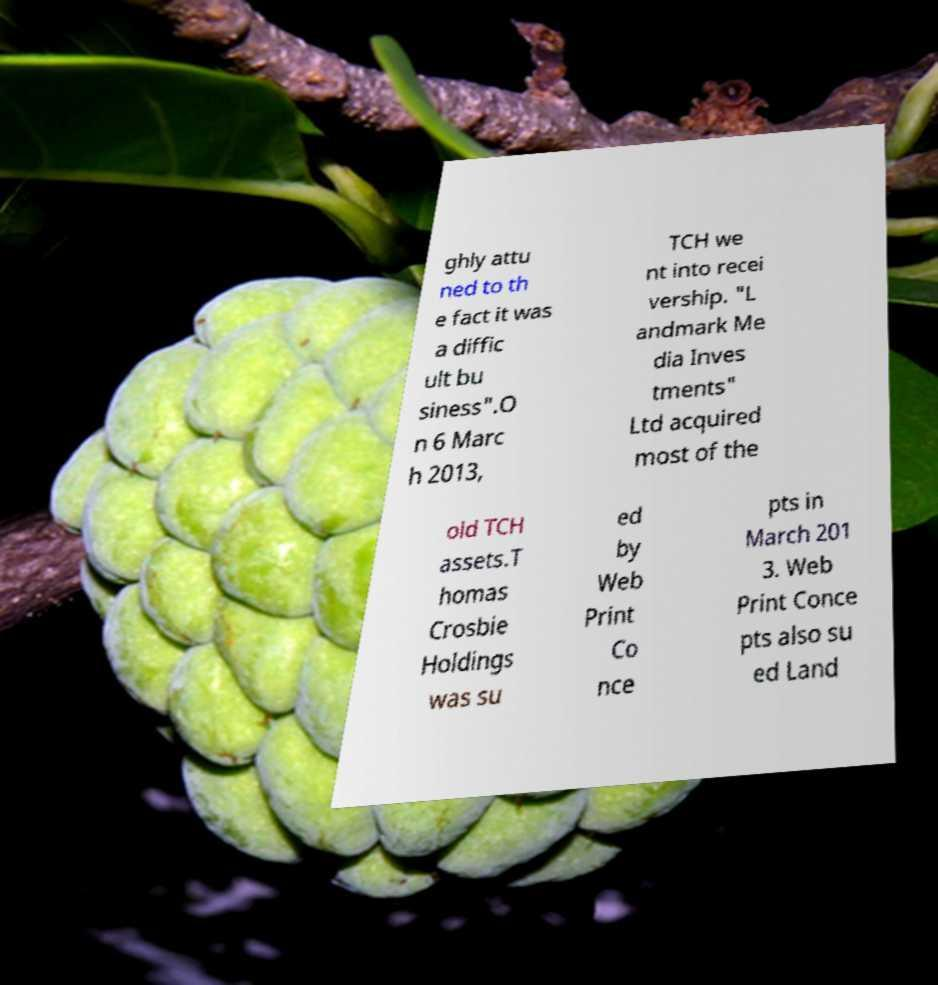Can you read and provide the text displayed in the image?This photo seems to have some interesting text. Can you extract and type it out for me? ghly attu ned to th e fact it was a diffic ult bu siness".O n 6 Marc h 2013, TCH we nt into recei vership. "L andmark Me dia Inves tments" Ltd acquired most of the old TCH assets.T homas Crosbie Holdings was su ed by Web Print Co nce pts in March 201 3. Web Print Conce pts also su ed Land 